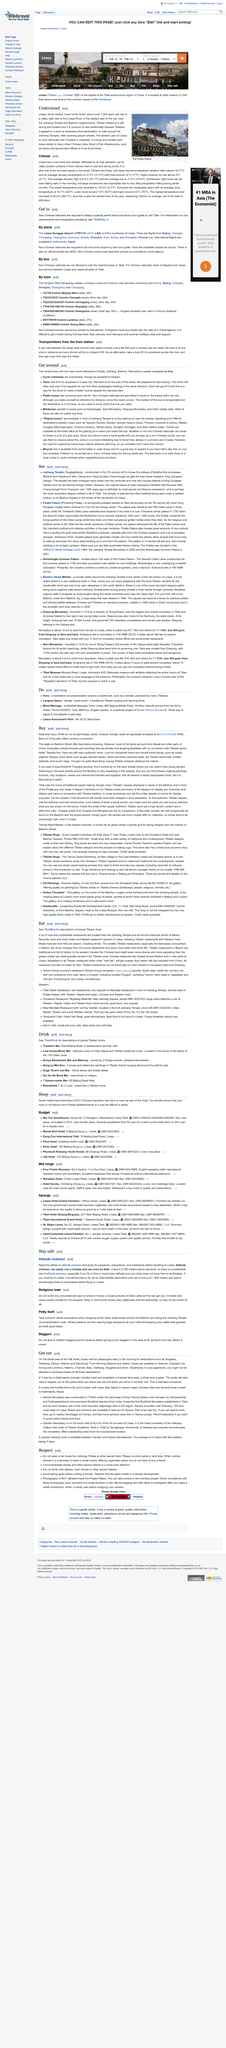Mention a couple of crucial points in this snapshot. A 7-day trip to Kathmandu typically includes accommodation and breakfast, a 4-wheel drive jeep, a driver, and a guide, all of which are essential components of the trip that provide the necessary support and assistance to the traveler. The long distance bus station has buses that travel to various destinations, including Golmud, Chengdu, Natchu, Chamdo, Bayi, Tsethang, Shigatse, and Dramo. The image on the right was taken in Lhasa. The buses travel along the street east of the Yak Hotel, making stops at Shigatse, Tsethang, Smaye, Nakchu, and Danzhung. Lhasa, which means "Land of the Gods," is a city in Tibet that is known for its rich spiritual history and stunning natural beauty. 